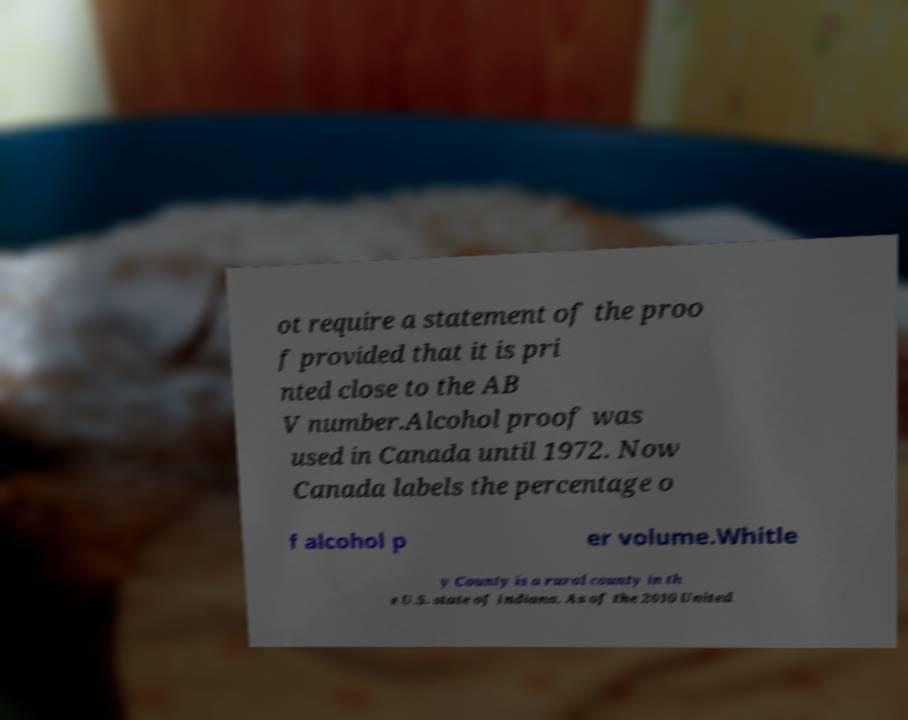Please read and relay the text visible in this image. What does it say? ot require a statement of the proo f provided that it is pri nted close to the AB V number.Alcohol proof was used in Canada until 1972. Now Canada labels the percentage o f alcohol p er volume.Whitle y County is a rural county in th e U.S. state of Indiana. As of the 2010 United 